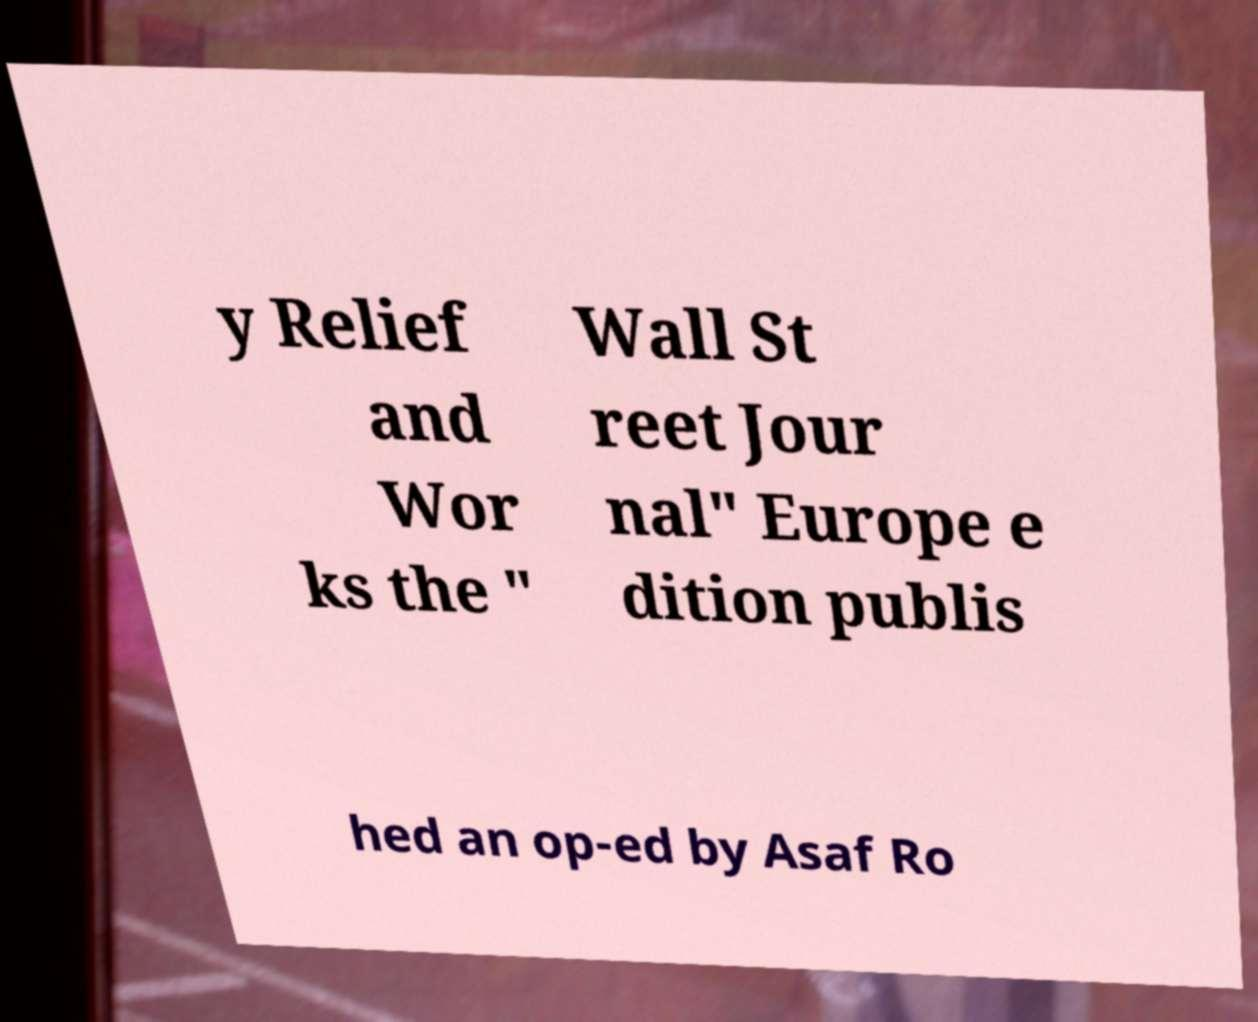Could you assist in decoding the text presented in this image and type it out clearly? y Relief and Wor ks the " Wall St reet Jour nal" Europe e dition publis hed an op-ed by Asaf Ro 